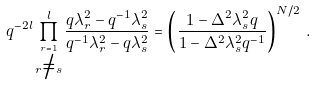<formula> <loc_0><loc_0><loc_500><loc_500>q ^ { - 2 l } \prod _ { { \stackrel { r = 1 } { r \not = s } } } ^ { l } \frac { q \lambda _ { r } ^ { 2 } - q ^ { - 1 } \lambda _ { s } ^ { 2 } } { q ^ { - 1 } \lambda _ { r } ^ { 2 } - q \lambda _ { s } ^ { 2 } } = \left ( \frac { 1 - \Delta ^ { 2 } \lambda _ { s } ^ { 2 } q } { 1 - \Delta ^ { 2 } \lambda _ { s } ^ { 2 } q ^ { - 1 } } \right ) ^ { N / 2 } \, .</formula> 